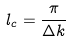<formula> <loc_0><loc_0><loc_500><loc_500>l _ { c } = { \frac { \pi } { \Delta k } }</formula> 